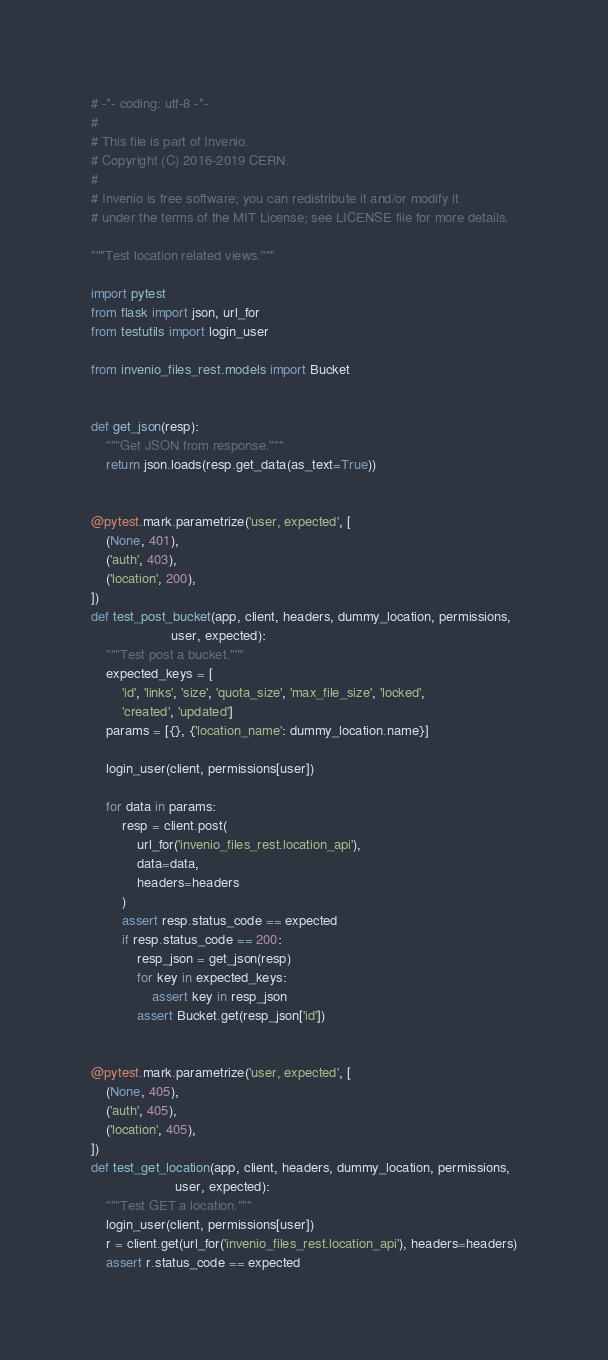Convert code to text. <code><loc_0><loc_0><loc_500><loc_500><_Python_># -*- coding: utf-8 -*-
#
# This file is part of Invenio.
# Copyright (C) 2016-2019 CERN.
#
# Invenio is free software; you can redistribute it and/or modify it
# under the terms of the MIT License; see LICENSE file for more details.

"""Test location related views."""

import pytest
from flask import json, url_for
from testutils import login_user

from invenio_files_rest.models import Bucket


def get_json(resp):
    """Get JSON from response."""
    return json.loads(resp.get_data(as_text=True))


@pytest.mark.parametrize('user, expected', [
    (None, 401),
    ('auth', 403),
    ('location', 200),
])
def test_post_bucket(app, client, headers, dummy_location, permissions,
                     user, expected):
    """Test post a bucket."""
    expected_keys = [
        'id', 'links', 'size', 'quota_size', 'max_file_size', 'locked',
        'created', 'updated']
    params = [{}, {'location_name': dummy_location.name}]

    login_user(client, permissions[user])

    for data in params:
        resp = client.post(
            url_for('invenio_files_rest.location_api'),
            data=data,
            headers=headers
        )
        assert resp.status_code == expected
        if resp.status_code == 200:
            resp_json = get_json(resp)
            for key in expected_keys:
                assert key in resp_json
            assert Bucket.get(resp_json['id'])


@pytest.mark.parametrize('user, expected', [
    (None, 405),
    ('auth', 405),
    ('location', 405),
])
def test_get_location(app, client, headers, dummy_location, permissions,
                      user, expected):
    """Test GET a location."""
    login_user(client, permissions[user])
    r = client.get(url_for('invenio_files_rest.location_api'), headers=headers)
    assert r.status_code == expected
</code> 